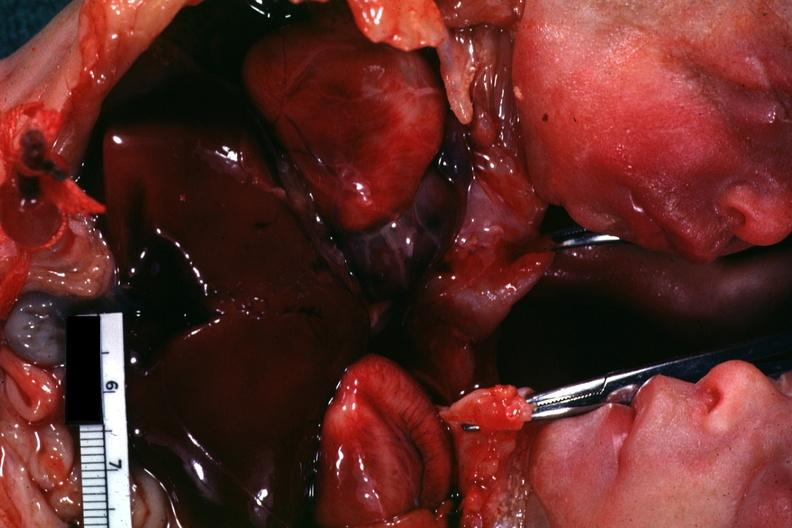what is this joined?
Answer the question using a single word or phrase. Chest and abdomen slide shows opened chest with two hearts 